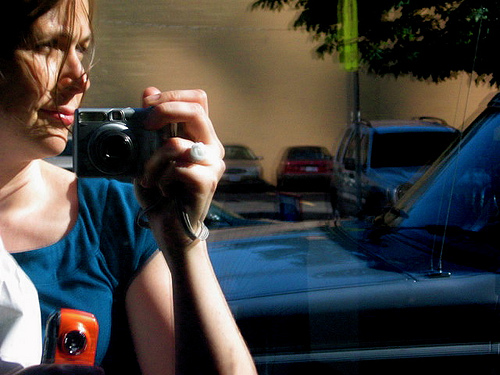What does the reflection in the window tell us about the environment outside? The reflection in the window shows a street with vehicles parked alongside the pavement, indicating an urban setting. The absence of movement in the reflection suggests the photo wasn't taken during rush hour or in a particularly busy location at the moment of capture. 